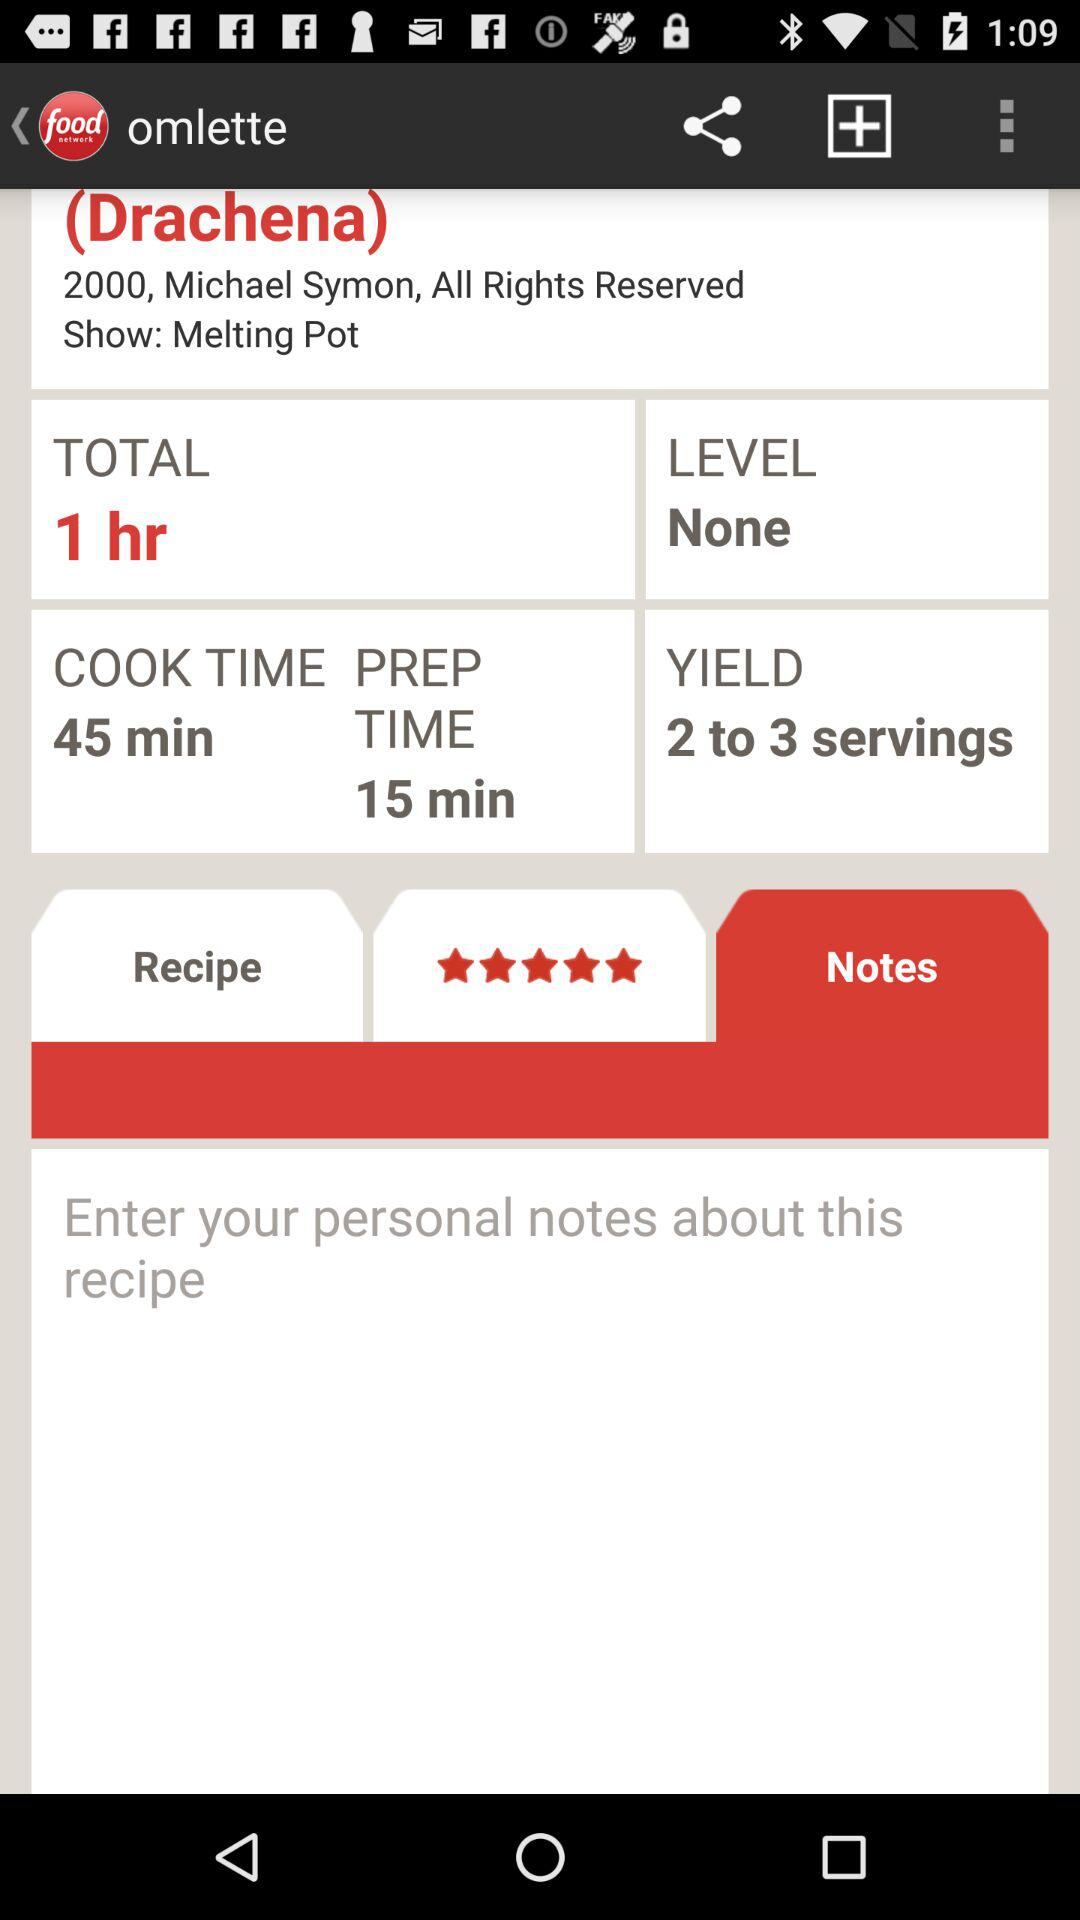How much is the prep time? The prep time is 15 minutes. 